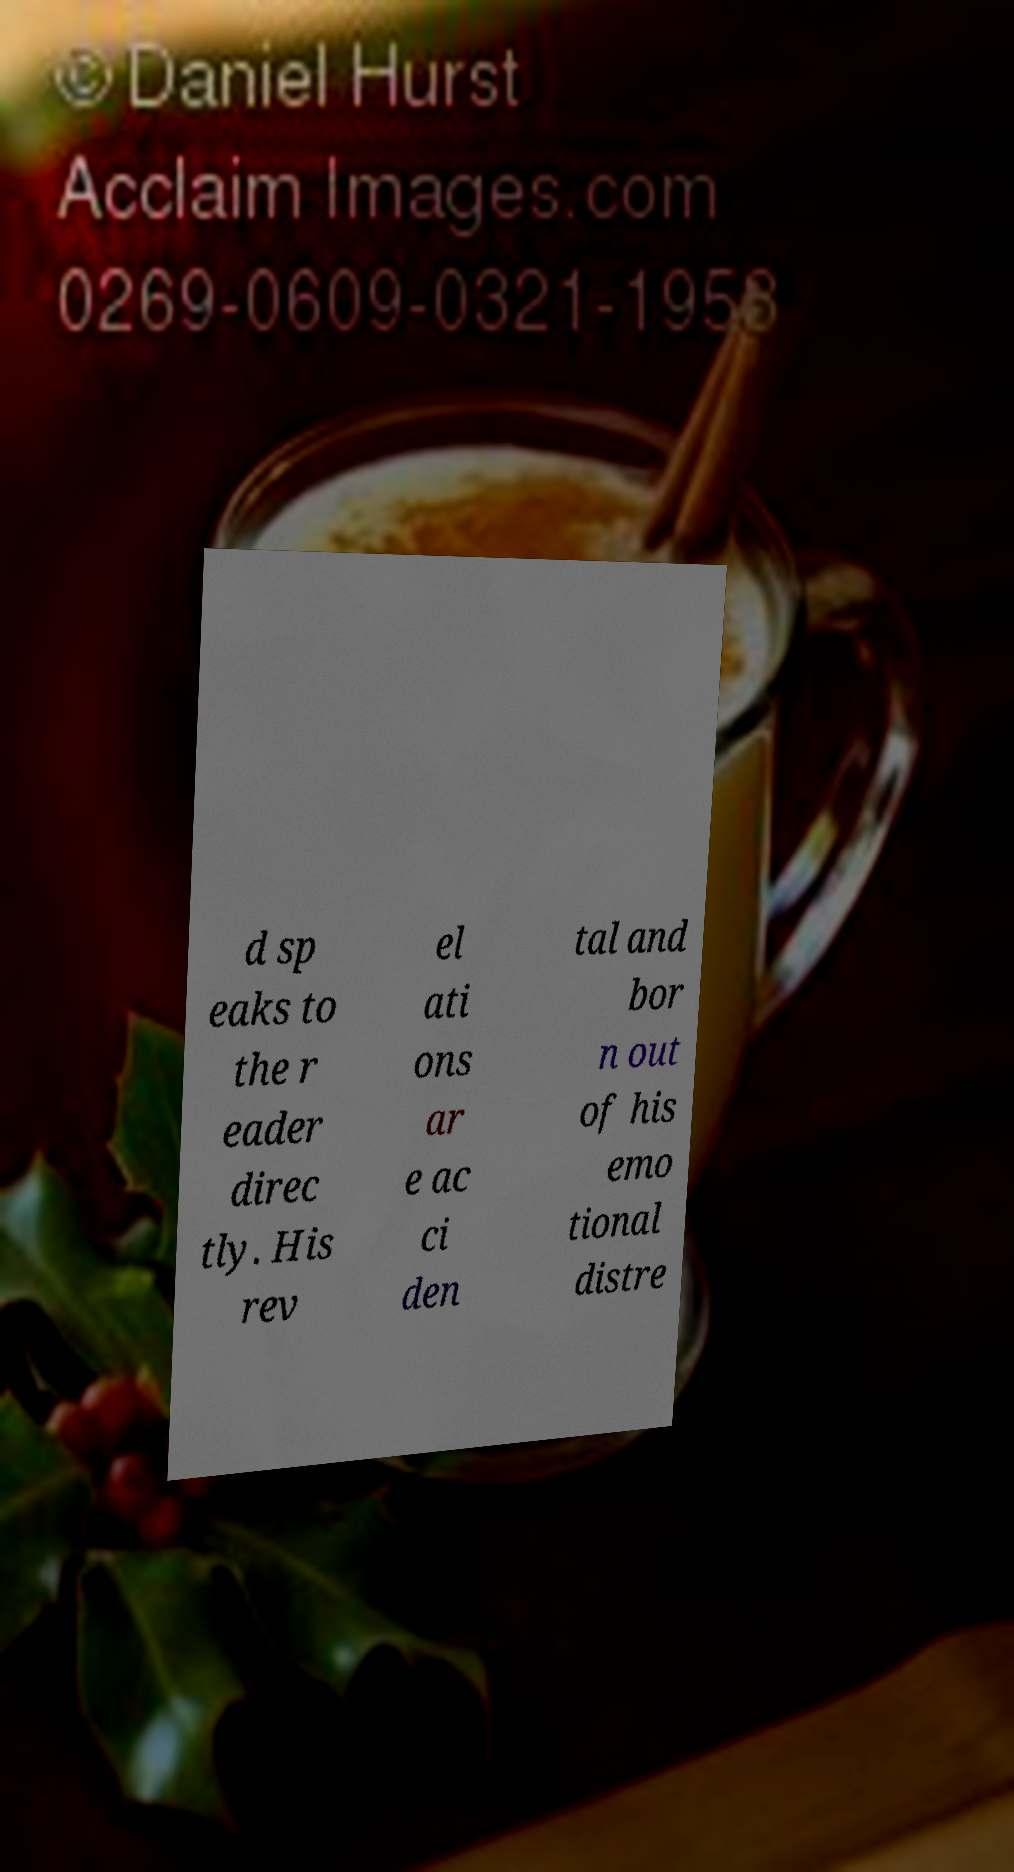For documentation purposes, I need the text within this image transcribed. Could you provide that? d sp eaks to the r eader direc tly. His rev el ati ons ar e ac ci den tal and bor n out of his emo tional distre 